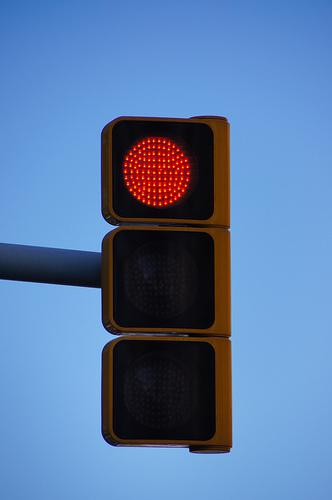Question: how many lights are not lit?
Choices:
A. 8.
B. 2.
C. 5.
D. 4.
Answer with the letter. Answer: B Question: why is the stop light red?
Choices:
A. To indicate a stop.
B. It changed from yellow.
C. It malfunctioned.
D. It is always red.
Answer with the letter. Answer: A Question: what color is the sky?
Choices:
A. Blue.
B. Purple.
C. Yellow.
D. Orange.
Answer with the letter. Answer: A Question: what color is the light on?
Choices:
A. Green.
B. Yellow.
C. Red.
D. Orange.
Answer with the letter. Answer: C Question: what is the traffic light hanging from?
Choices:
A. A cable.
B. A hook.
C. A pole.
D. A bracket.
Answer with the letter. Answer: C 